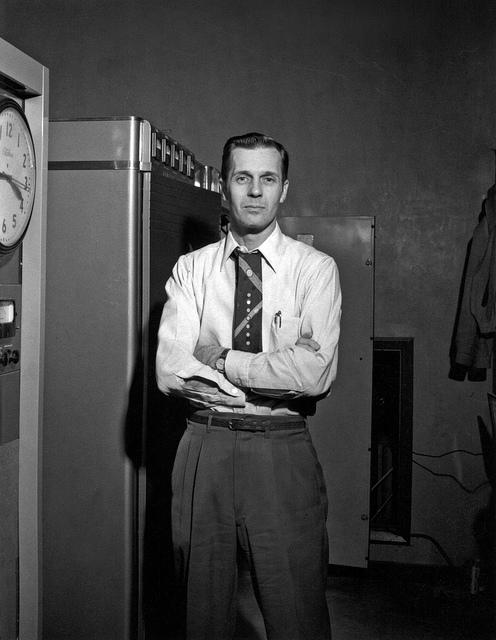What color scheme is this photo taken in?
Write a very short answer. Black and white. Are there visual clues that date this photo?
Answer briefly. No. What time is shown on the clock?
Concise answer only. 3:45. 